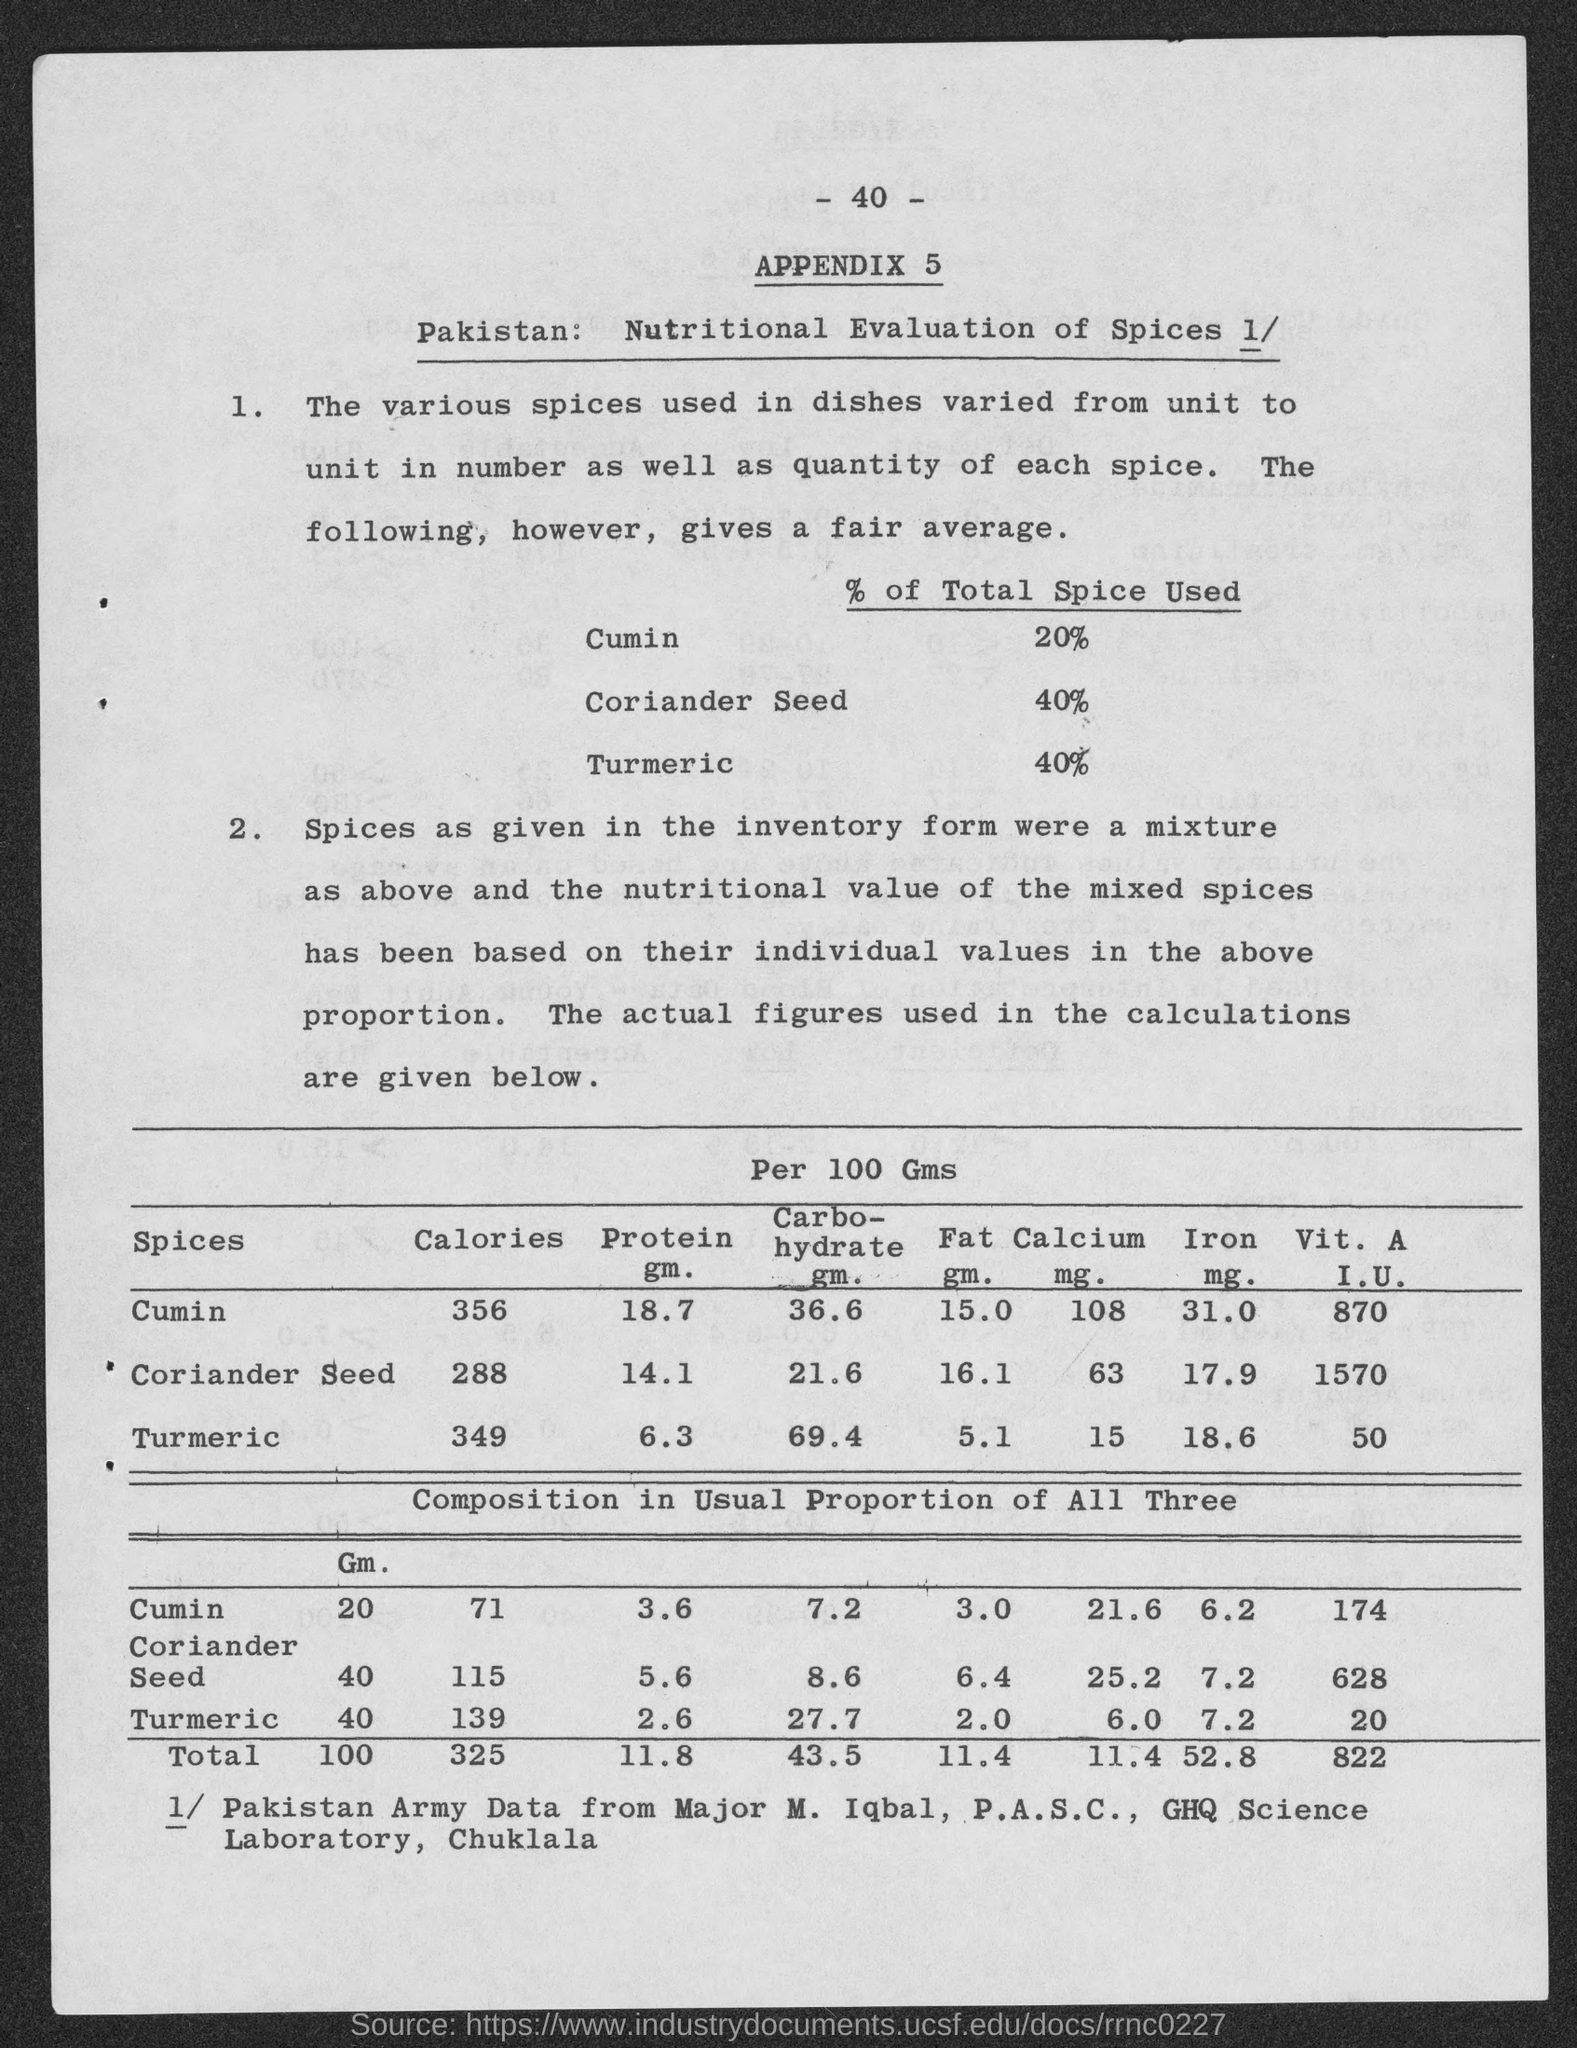What can this page tell us about dietary habits? The page gives insights into dietary habits by highlighting the proportions of different spices in dishes, which suggests a preference for certain flavors. For example, coriander seed and turmeric are used most commonly, each making up 40% of the total spice used in the average mixture according to this sample. This not only reflects culinary preferences but can also indicate the nutritional contributions spices make to the overall diet. 